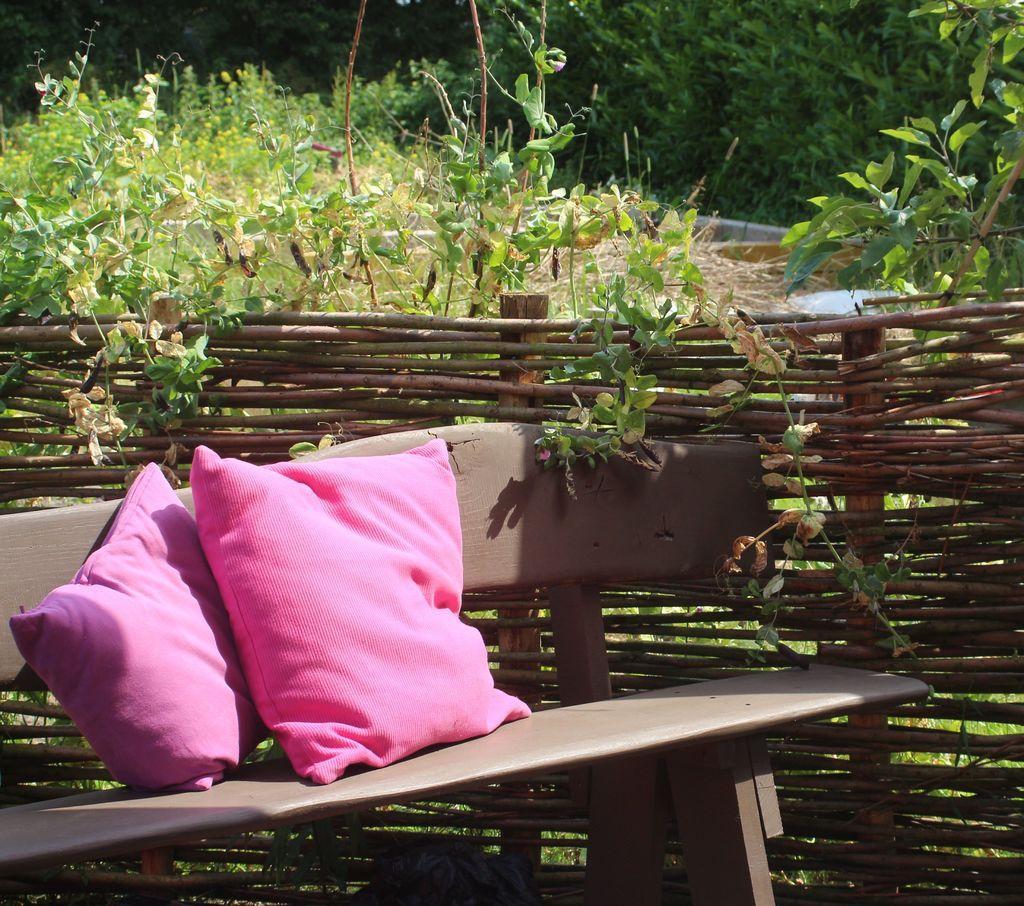How would you summarize this image in a sentence or two? In the foreground of the picture there are plants, bench, pillows and a wooden fencing. In the background there are trees and grass. 